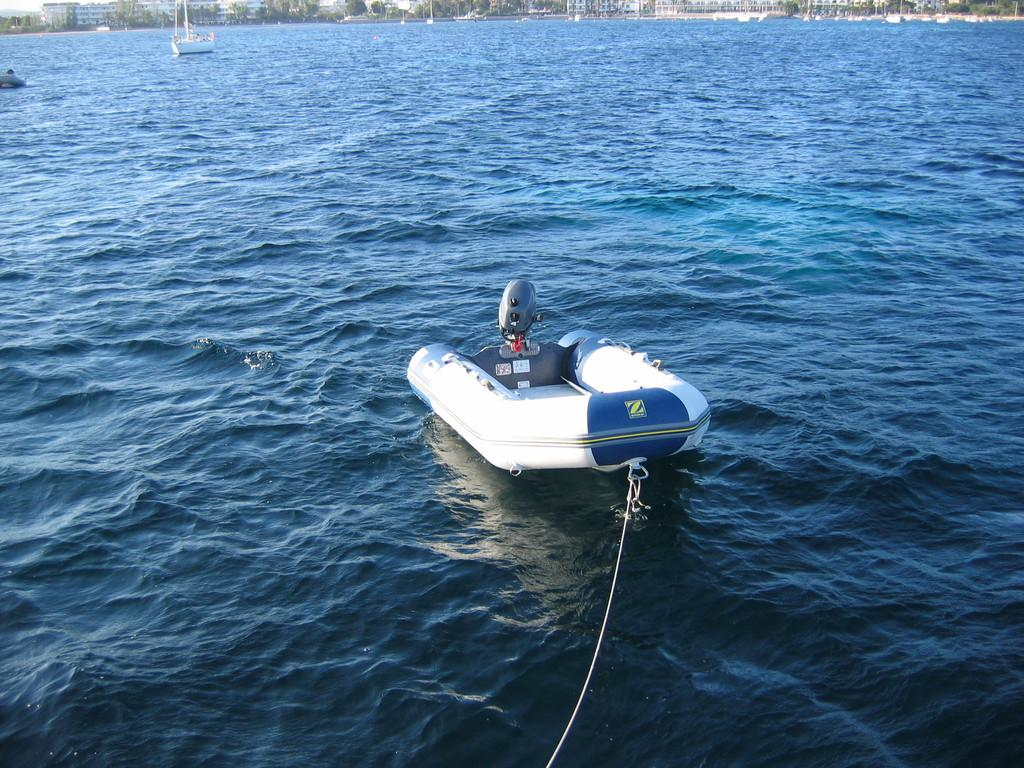<image>
Write a terse but informative summary of the picture. Blue and white boat with the letter Z on the back. 